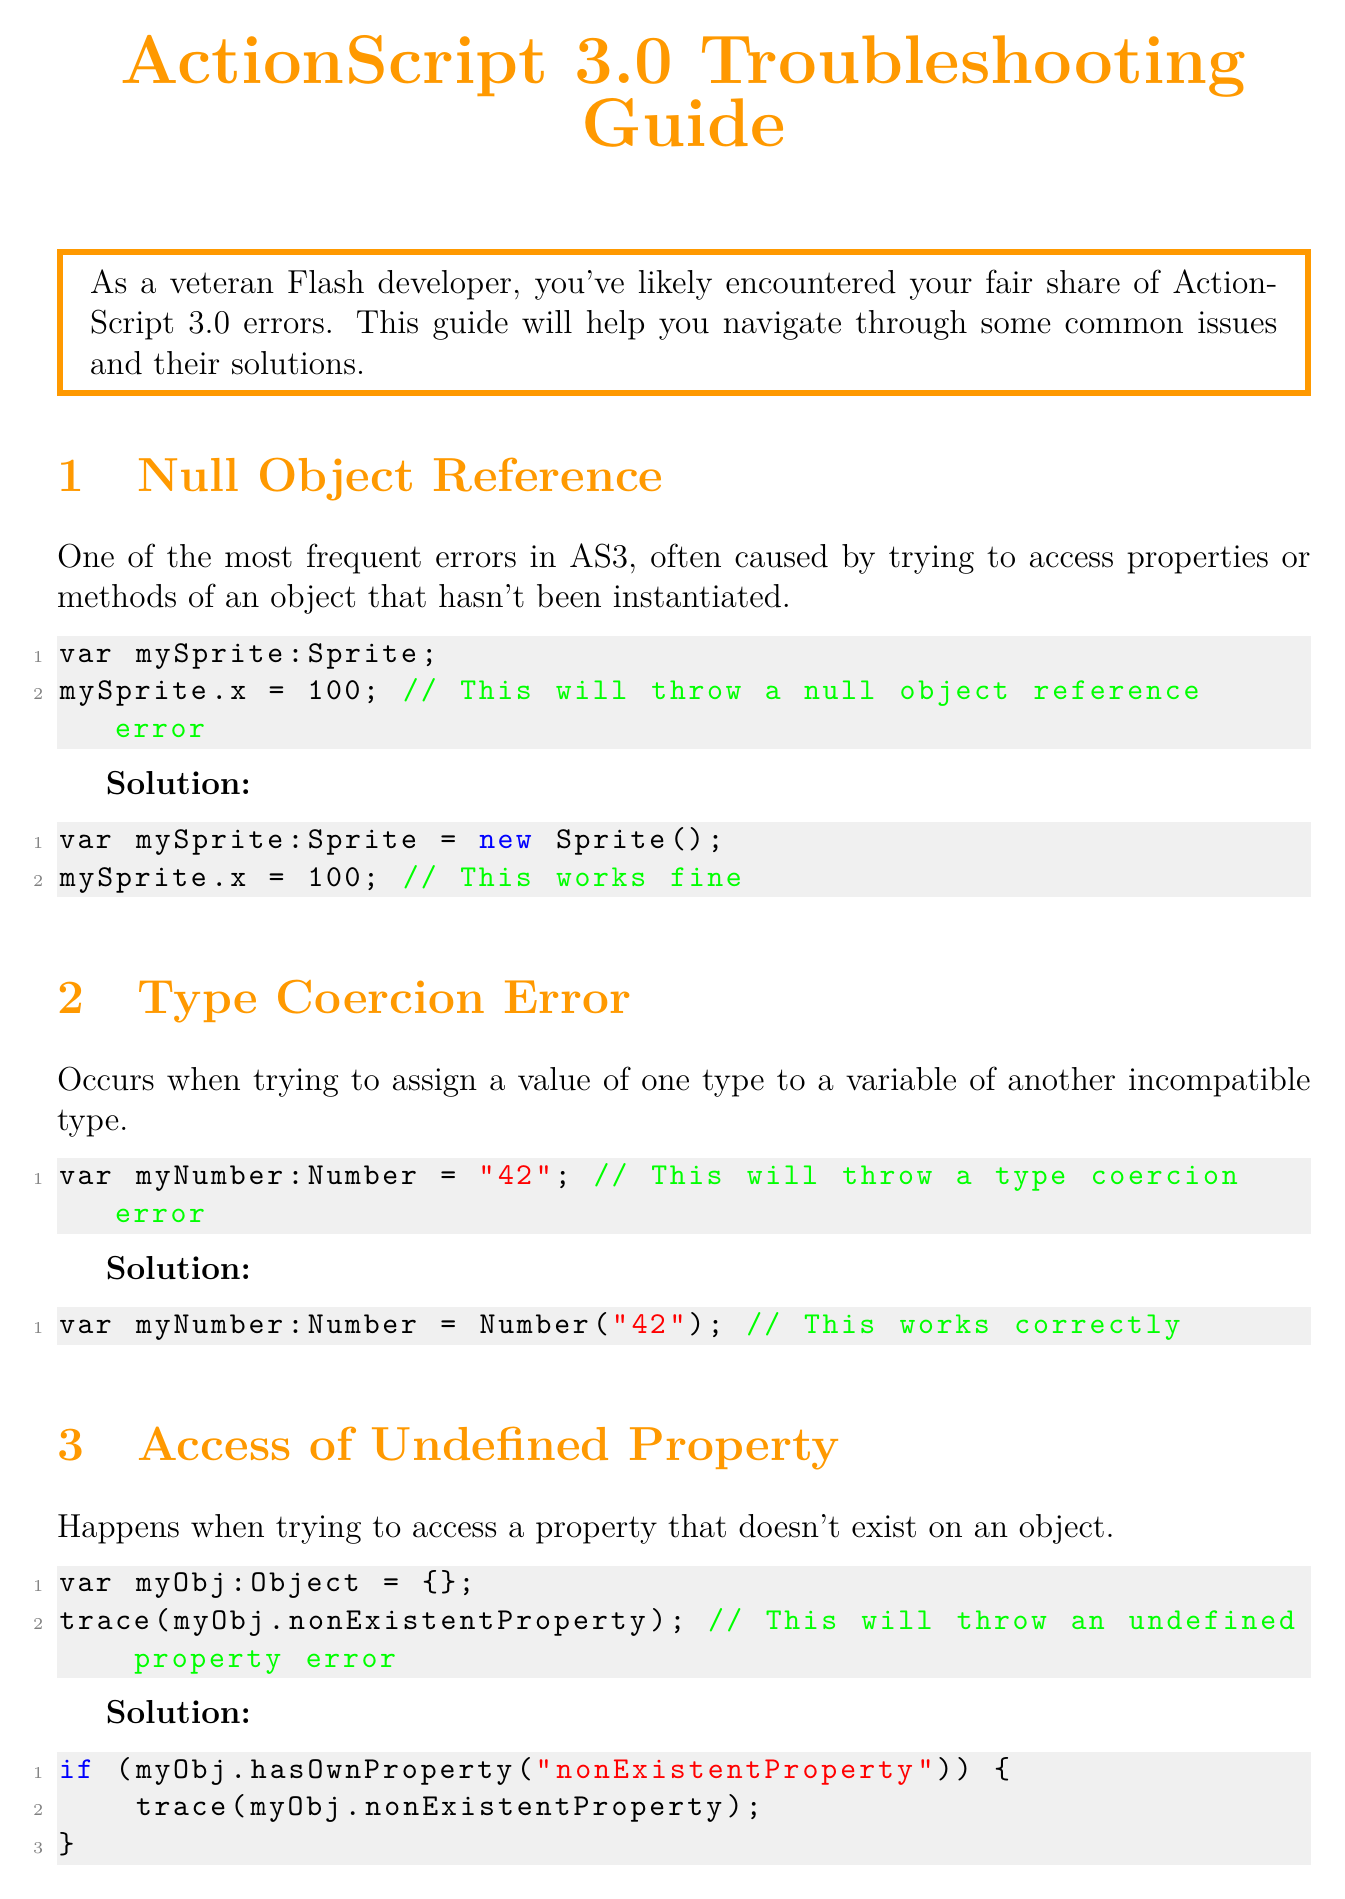What is the title of the guide? The title of the guide is specified at the beginning of the document.
Answer: ActionScript 3.0 Troubleshooting Guide What is a common cause of the Null Object Reference error? The document explains that this error is caused by trying to access properties or methods of an object that hasn't been instantiated.
Answer: Not instantiated What is the solution for a Type Coercion Error? The document provides an example of converting a string to a number as a solution for this error.
Answer: Number conversion What is recommended to manage memory effectively? The guide suggests removing unnecessary event listeners and cleaning up objects when they are no longer needed.
Answer: Remove event listeners Which function is highlighted as helpful for troubleshooting? The document mentions a specific function that is useful for debugging and troubleshooting errors.
Answer: trace What does the guide suggest for debugging in the IDE? It emphasizes the importance of using a particular debugging feature in the Integrated Development Environment.
Answer: Breakpoints How many sections are covered in the troubleshooting guide? The number of distinct issues addressed within the guide can be found by counting the listed sections.
Answer: Four What color is used for the section titles? The document refers to a specific color used for the titles of each section throughout the content.
Answer: Flash orange What is the main focus of the introduction? The introduction sets the stage for a specific aspect of ActionScript development.
Answer: Common errors 